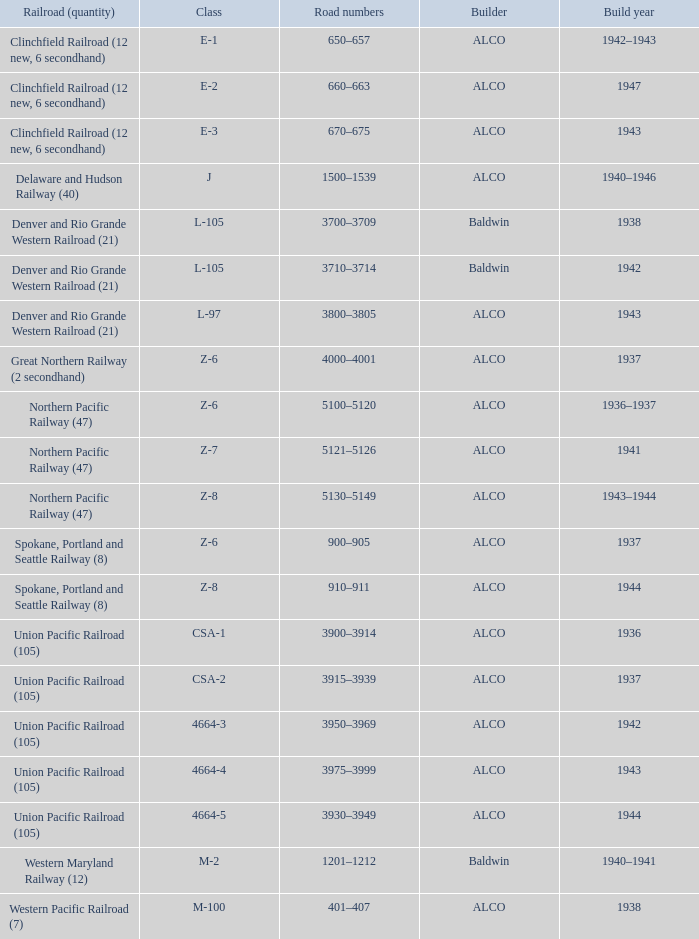Could you parse the entire table as a dict? {'header': ['Railroad (quantity)', 'Class', 'Road numbers', 'Builder', 'Build year'], 'rows': [['Clinchfield Railroad (12 new, 6 secondhand)', 'E-1', '650–657', 'ALCO', '1942–1943'], ['Clinchfield Railroad (12 new, 6 secondhand)', 'E-2', '660–663', 'ALCO', '1947'], ['Clinchfield Railroad (12 new, 6 secondhand)', 'E-3', '670–675', 'ALCO', '1943'], ['Delaware and Hudson Railway (40)', 'J', '1500–1539', 'ALCO', '1940–1946'], ['Denver and Rio Grande Western Railroad (21)', 'L-105', '3700–3709', 'Baldwin', '1938'], ['Denver and Rio Grande Western Railroad (21)', 'L-105', '3710–3714', 'Baldwin', '1942'], ['Denver and Rio Grande Western Railroad (21)', 'L-97', '3800–3805', 'ALCO', '1943'], ['Great Northern Railway (2 secondhand)', 'Z-6', '4000–4001', 'ALCO', '1937'], ['Northern Pacific Railway (47)', 'Z-6', '5100–5120', 'ALCO', '1936–1937'], ['Northern Pacific Railway (47)', 'Z-7', '5121–5126', 'ALCO', '1941'], ['Northern Pacific Railway (47)', 'Z-8', '5130–5149', 'ALCO', '1943–1944'], ['Spokane, Portland and Seattle Railway (8)', 'Z-6', '900–905', 'ALCO', '1937'], ['Spokane, Portland and Seattle Railway (8)', 'Z-8', '910–911', 'ALCO', '1944'], ['Union Pacific Railroad (105)', 'CSA-1', '3900–3914', 'ALCO', '1936'], ['Union Pacific Railroad (105)', 'CSA-2', '3915–3939', 'ALCO', '1937'], ['Union Pacific Railroad (105)', '4664-3', '3950–3969', 'ALCO', '1942'], ['Union Pacific Railroad (105)', '4664-4', '3975–3999', 'ALCO', '1943'], ['Union Pacific Railroad (105)', '4664-5', '3930–3949', 'ALCO', '1944'], ['Western Maryland Railway (12)', 'M-2', '1201–1212', 'Baldwin', '1940–1941'], ['Western Pacific Railroad (7)', 'M-100', '401–407', 'ALCO', '1938']]} What are the street figures when the developer is alco, the railroad (number) is union pacific railroad (105), and the classification is csa-2? 3915–3939. 